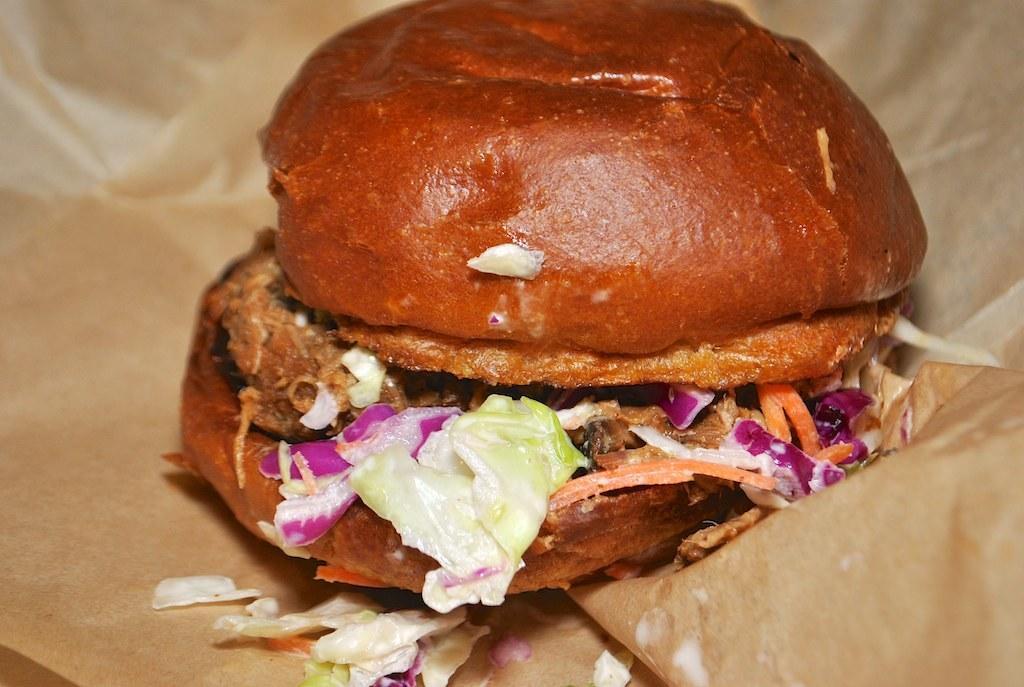In one or two sentences, can you explain what this image depicts? In this picture we can see there is bread and some ingredients on the paper. 